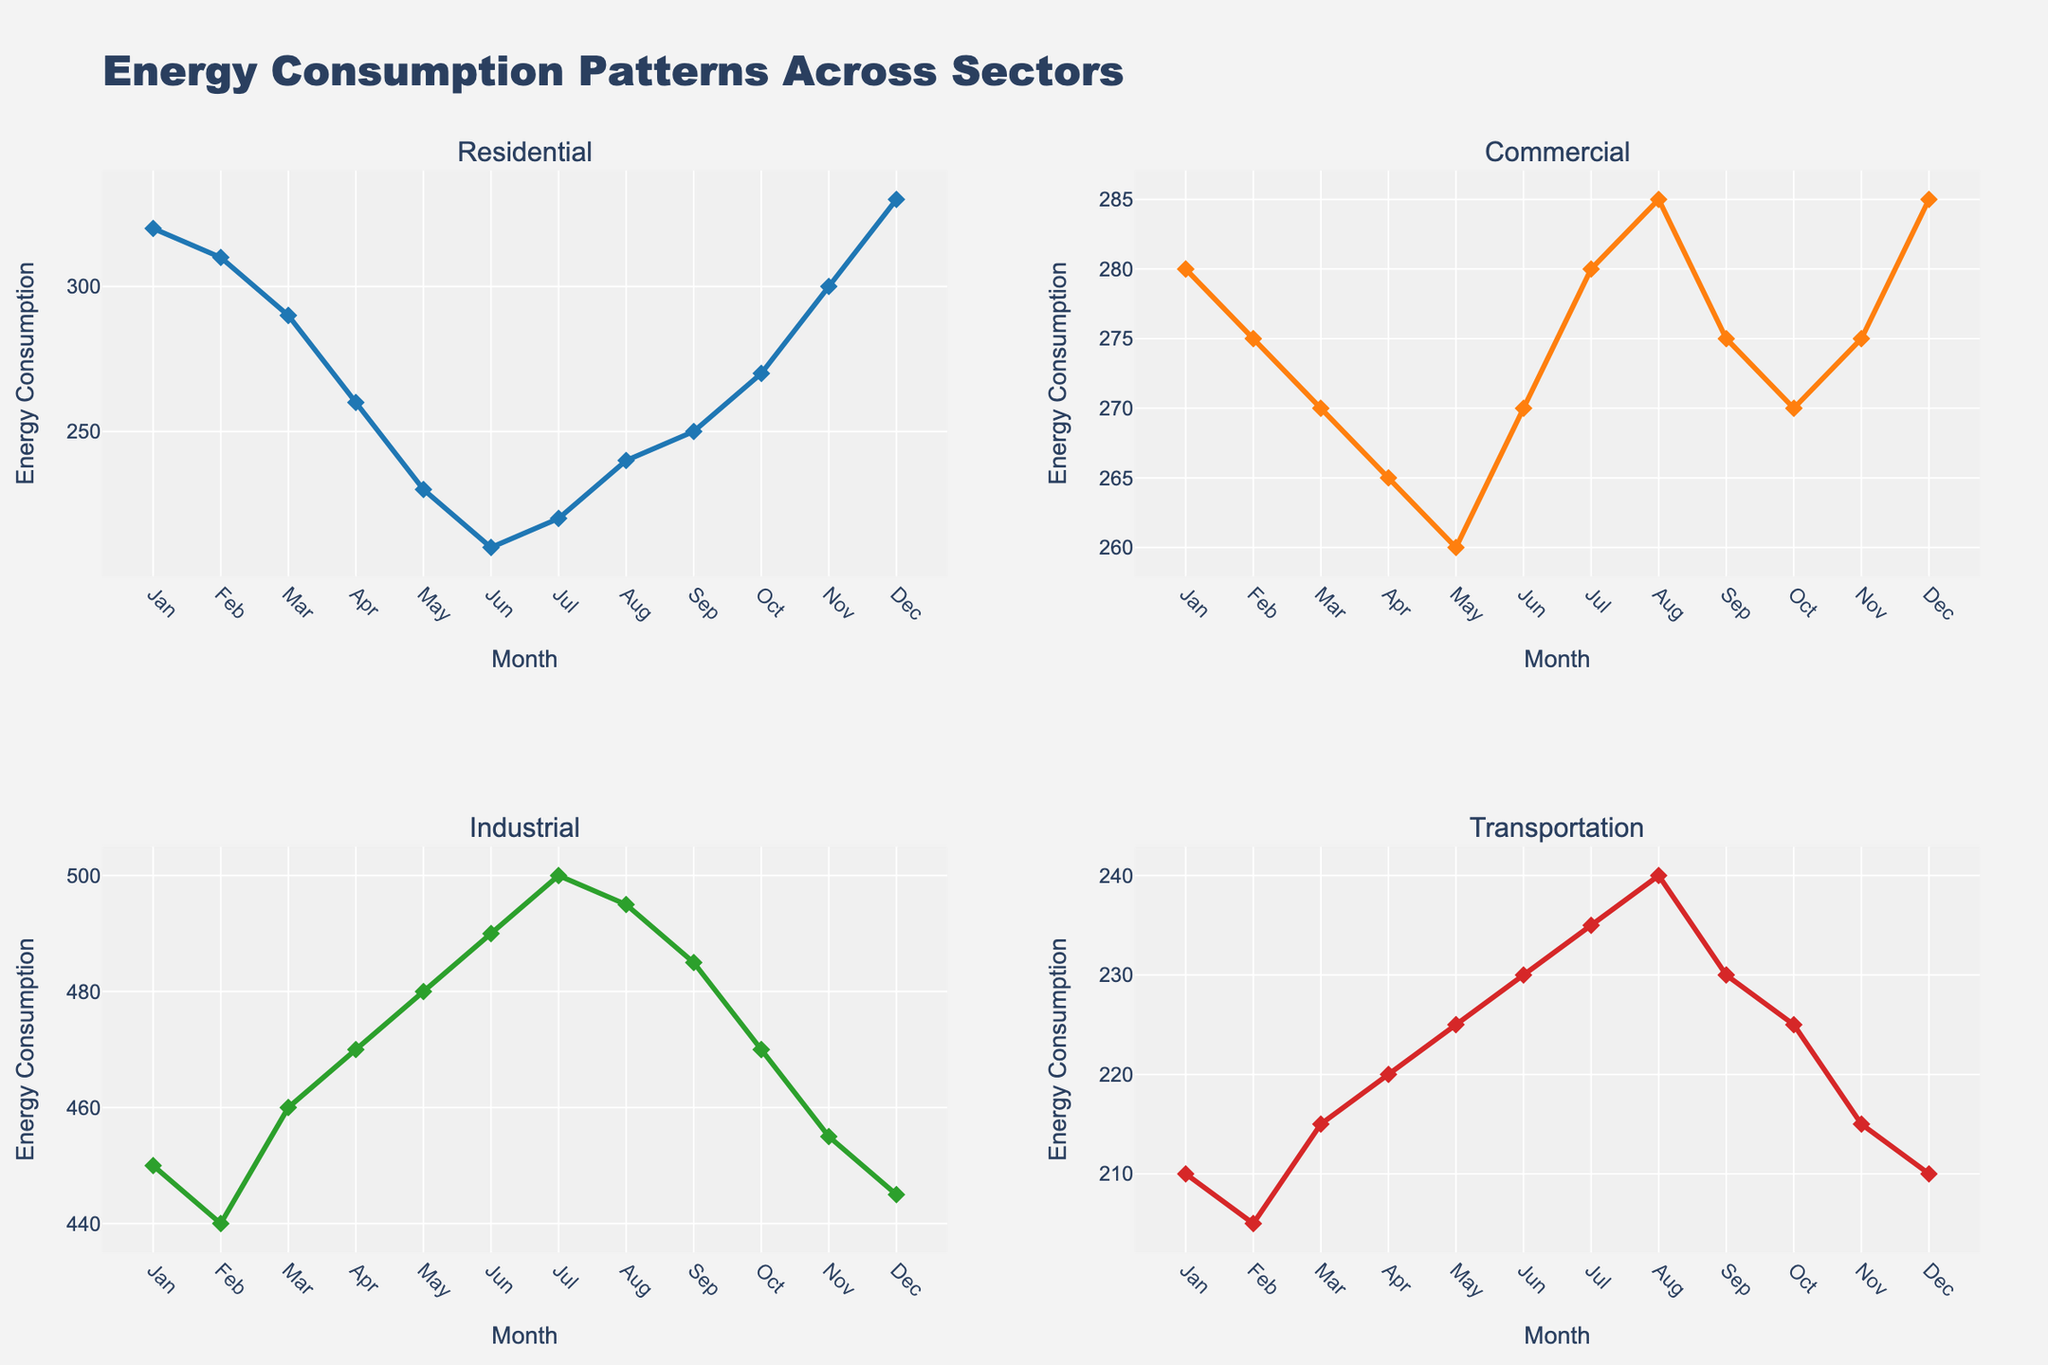How many subplots are there in the figure? The figure has 4 subplots, one for each sector: Residential, Commercial, Industrial, and Transportation. These subplots are arranged in a 2x2 grid.
Answer: 4 What is the title of the entire figure? The title of the figure is "Energy Consumption Patterns Across Sectors". This is displayed prominently at the top of the figure.
Answer: Energy Consumption Patterns Across Sectors What is the trend in the "Residential" energy consumption from January to December? "Residential" energy consumption generally decreases from January (320) to June (210), then increases again towards December (330). This trend can be observed by following the line plot in the "Residential" subplot.
Answer: Decreases then increases Which month has the highest energy consumption in the "Industrial" sector? By looking at the "Industrial" subplot, we can see that the line reaches its highest point in July, with a value of 500.
Answer: July Compare the energy consumption in "Commercial" and "Transportation" sectors during August. Which is higher? In August, "Commercial" has a value of 285 while "Transportation" has a value of 240. Comparing these values shows that "Commercial" is higher.
Answer: Commercial is higher On average, which sector uses the most energy, based on the subplots? To determine this, we average the energy consumption values for each sector. Adding and dividing the totals for Residential (3260/12), Commercial (3240/12), Industrial (5610/12), and Transportation (2700/12), we find that Industrial has the highest average consumption.
Answer: Industrial Which sector shows the least variability in energy consumption throughout the year? "Commercial" sector has the least variability as the line is the flattest with values ranging closely from 260 to 285, indicating minimal fluctuation.
Answer: Commercial Is there any month where all sectors show increasing energy consumption compared to the previous month? By checking the subplots, in April compared to March, all sectors (Residential, Commercial, Industrial, and Transportation) show an increase.
Answer: April What is the difference in energy consumption between the highest and lowest months for the "Residential" sector? The highest is December (330) and the lowest is June (210). The difference between these values is 330 - 210 = 120.
Answer: 120 Which sector shows a peak in energy consumption during summer months (June, July, August)? The "Industrial" sector shows a peak in July during the summer months with a value of 500, the highest in its subplot.
Answer: Industrial 